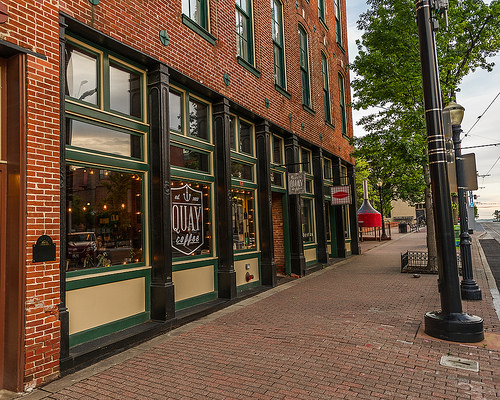<image>
Can you confirm if the cafe is on the street? Yes. Looking at the image, I can see the cafe is positioned on top of the street, with the street providing support. 